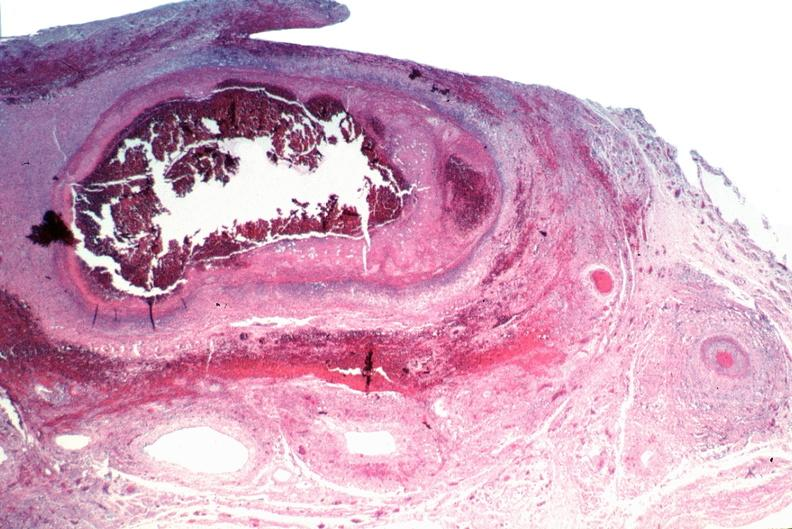s vasculature present?
Answer the question using a single word or phrase. Yes 